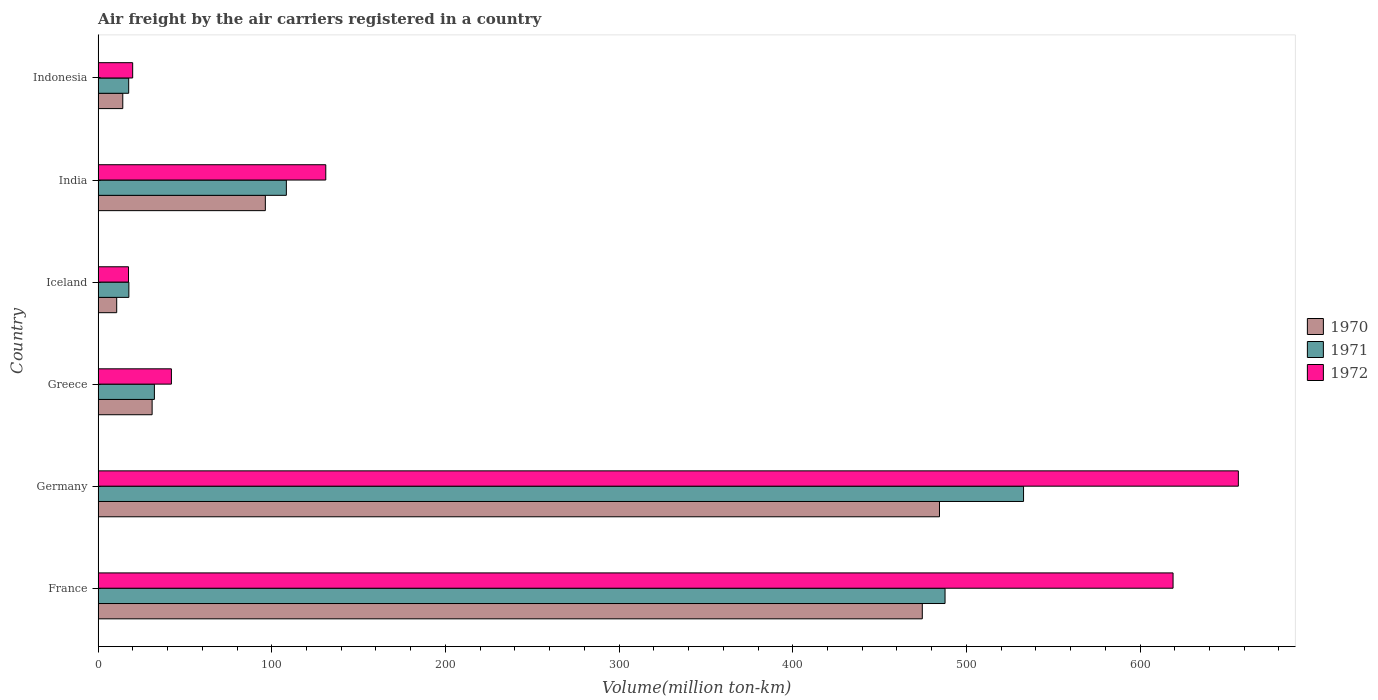How many groups of bars are there?
Ensure brevity in your answer.  6. Are the number of bars on each tick of the Y-axis equal?
Offer a very short reply. Yes. How many bars are there on the 6th tick from the top?
Offer a very short reply. 3. How many bars are there on the 3rd tick from the bottom?
Provide a short and direct response. 3. What is the label of the 6th group of bars from the top?
Ensure brevity in your answer.  France. What is the volume of the air carriers in 1972 in Iceland?
Provide a short and direct response. 17.5. Across all countries, what is the maximum volume of the air carriers in 1971?
Your answer should be compact. 532.9. Across all countries, what is the minimum volume of the air carriers in 1971?
Keep it short and to the point. 17.6. In which country was the volume of the air carriers in 1972 minimum?
Ensure brevity in your answer.  Iceland. What is the total volume of the air carriers in 1972 in the graph?
Offer a very short reply. 1486.3. What is the difference between the volume of the air carriers in 1970 in Germany and that in Iceland?
Your answer should be very brief. 473.8. What is the difference between the volume of the air carriers in 1971 in Greece and the volume of the air carriers in 1972 in Indonesia?
Your response must be concise. 12.5. What is the average volume of the air carriers in 1972 per country?
Your response must be concise. 247.72. What is the difference between the volume of the air carriers in 1970 and volume of the air carriers in 1972 in Germany?
Offer a very short reply. -172.1. What is the ratio of the volume of the air carriers in 1970 in France to that in Indonesia?
Ensure brevity in your answer.  33.42. What is the difference between the highest and the second highest volume of the air carriers in 1972?
Make the answer very short. 37.6. What is the difference between the highest and the lowest volume of the air carriers in 1972?
Make the answer very short. 639.1. What does the 2nd bar from the bottom in Germany represents?
Your answer should be very brief. 1971. How many bars are there?
Give a very brief answer. 18. How many countries are there in the graph?
Offer a very short reply. 6. Are the values on the major ticks of X-axis written in scientific E-notation?
Give a very brief answer. No. Does the graph contain any zero values?
Offer a terse response. No. Does the graph contain grids?
Offer a very short reply. No. How many legend labels are there?
Offer a terse response. 3. What is the title of the graph?
Offer a very short reply. Air freight by the air carriers registered in a country. What is the label or title of the X-axis?
Your answer should be very brief. Volume(million ton-km). What is the Volume(million ton-km) of 1970 in France?
Keep it short and to the point. 474.6. What is the Volume(million ton-km) in 1971 in France?
Keep it short and to the point. 487.7. What is the Volume(million ton-km) of 1972 in France?
Offer a terse response. 619. What is the Volume(million ton-km) of 1970 in Germany?
Offer a very short reply. 484.5. What is the Volume(million ton-km) of 1971 in Germany?
Your answer should be very brief. 532.9. What is the Volume(million ton-km) in 1972 in Germany?
Keep it short and to the point. 656.6. What is the Volume(million ton-km) of 1970 in Greece?
Provide a succinct answer. 31.1. What is the Volume(million ton-km) in 1971 in Greece?
Make the answer very short. 32.4. What is the Volume(million ton-km) of 1972 in Greece?
Keep it short and to the point. 42.2. What is the Volume(million ton-km) of 1970 in Iceland?
Offer a terse response. 10.7. What is the Volume(million ton-km) of 1971 in Iceland?
Your answer should be very brief. 17.7. What is the Volume(million ton-km) of 1970 in India?
Ensure brevity in your answer.  96.3. What is the Volume(million ton-km) in 1971 in India?
Offer a very short reply. 108.4. What is the Volume(million ton-km) of 1972 in India?
Provide a succinct answer. 131.1. What is the Volume(million ton-km) in 1970 in Indonesia?
Give a very brief answer. 14.2. What is the Volume(million ton-km) in 1971 in Indonesia?
Give a very brief answer. 17.6. What is the Volume(million ton-km) of 1972 in Indonesia?
Offer a very short reply. 19.9. Across all countries, what is the maximum Volume(million ton-km) of 1970?
Your answer should be very brief. 484.5. Across all countries, what is the maximum Volume(million ton-km) of 1971?
Provide a succinct answer. 532.9. Across all countries, what is the maximum Volume(million ton-km) in 1972?
Keep it short and to the point. 656.6. Across all countries, what is the minimum Volume(million ton-km) in 1970?
Keep it short and to the point. 10.7. Across all countries, what is the minimum Volume(million ton-km) of 1971?
Provide a short and direct response. 17.6. Across all countries, what is the minimum Volume(million ton-km) in 1972?
Make the answer very short. 17.5. What is the total Volume(million ton-km) in 1970 in the graph?
Your answer should be compact. 1111.4. What is the total Volume(million ton-km) of 1971 in the graph?
Offer a terse response. 1196.7. What is the total Volume(million ton-km) in 1972 in the graph?
Keep it short and to the point. 1486.3. What is the difference between the Volume(million ton-km) in 1970 in France and that in Germany?
Ensure brevity in your answer.  -9.9. What is the difference between the Volume(million ton-km) in 1971 in France and that in Germany?
Your response must be concise. -45.2. What is the difference between the Volume(million ton-km) in 1972 in France and that in Germany?
Offer a terse response. -37.6. What is the difference between the Volume(million ton-km) in 1970 in France and that in Greece?
Offer a terse response. 443.5. What is the difference between the Volume(million ton-km) of 1971 in France and that in Greece?
Offer a terse response. 455.3. What is the difference between the Volume(million ton-km) of 1972 in France and that in Greece?
Offer a terse response. 576.8. What is the difference between the Volume(million ton-km) in 1970 in France and that in Iceland?
Provide a short and direct response. 463.9. What is the difference between the Volume(million ton-km) of 1971 in France and that in Iceland?
Give a very brief answer. 470. What is the difference between the Volume(million ton-km) of 1972 in France and that in Iceland?
Give a very brief answer. 601.5. What is the difference between the Volume(million ton-km) of 1970 in France and that in India?
Ensure brevity in your answer.  378.3. What is the difference between the Volume(million ton-km) in 1971 in France and that in India?
Give a very brief answer. 379.3. What is the difference between the Volume(million ton-km) in 1972 in France and that in India?
Ensure brevity in your answer.  487.9. What is the difference between the Volume(million ton-km) in 1970 in France and that in Indonesia?
Give a very brief answer. 460.4. What is the difference between the Volume(million ton-km) of 1971 in France and that in Indonesia?
Make the answer very short. 470.1. What is the difference between the Volume(million ton-km) in 1972 in France and that in Indonesia?
Make the answer very short. 599.1. What is the difference between the Volume(million ton-km) in 1970 in Germany and that in Greece?
Keep it short and to the point. 453.4. What is the difference between the Volume(million ton-km) of 1971 in Germany and that in Greece?
Provide a short and direct response. 500.5. What is the difference between the Volume(million ton-km) in 1972 in Germany and that in Greece?
Your answer should be compact. 614.4. What is the difference between the Volume(million ton-km) of 1970 in Germany and that in Iceland?
Give a very brief answer. 473.8. What is the difference between the Volume(million ton-km) of 1971 in Germany and that in Iceland?
Provide a short and direct response. 515.2. What is the difference between the Volume(million ton-km) of 1972 in Germany and that in Iceland?
Your answer should be compact. 639.1. What is the difference between the Volume(million ton-km) in 1970 in Germany and that in India?
Provide a short and direct response. 388.2. What is the difference between the Volume(million ton-km) of 1971 in Germany and that in India?
Offer a very short reply. 424.5. What is the difference between the Volume(million ton-km) in 1972 in Germany and that in India?
Keep it short and to the point. 525.5. What is the difference between the Volume(million ton-km) of 1970 in Germany and that in Indonesia?
Provide a short and direct response. 470.3. What is the difference between the Volume(million ton-km) of 1971 in Germany and that in Indonesia?
Provide a short and direct response. 515.3. What is the difference between the Volume(million ton-km) of 1972 in Germany and that in Indonesia?
Ensure brevity in your answer.  636.7. What is the difference between the Volume(million ton-km) in 1970 in Greece and that in Iceland?
Your response must be concise. 20.4. What is the difference between the Volume(million ton-km) in 1972 in Greece and that in Iceland?
Make the answer very short. 24.7. What is the difference between the Volume(million ton-km) in 1970 in Greece and that in India?
Offer a very short reply. -65.2. What is the difference between the Volume(million ton-km) in 1971 in Greece and that in India?
Provide a short and direct response. -76. What is the difference between the Volume(million ton-km) in 1972 in Greece and that in India?
Provide a succinct answer. -88.9. What is the difference between the Volume(million ton-km) in 1970 in Greece and that in Indonesia?
Offer a very short reply. 16.9. What is the difference between the Volume(million ton-km) in 1972 in Greece and that in Indonesia?
Provide a succinct answer. 22.3. What is the difference between the Volume(million ton-km) of 1970 in Iceland and that in India?
Provide a succinct answer. -85.6. What is the difference between the Volume(million ton-km) of 1971 in Iceland and that in India?
Your answer should be very brief. -90.7. What is the difference between the Volume(million ton-km) in 1972 in Iceland and that in India?
Offer a very short reply. -113.6. What is the difference between the Volume(million ton-km) of 1972 in Iceland and that in Indonesia?
Ensure brevity in your answer.  -2.4. What is the difference between the Volume(million ton-km) of 1970 in India and that in Indonesia?
Provide a succinct answer. 82.1. What is the difference between the Volume(million ton-km) of 1971 in India and that in Indonesia?
Make the answer very short. 90.8. What is the difference between the Volume(million ton-km) in 1972 in India and that in Indonesia?
Give a very brief answer. 111.2. What is the difference between the Volume(million ton-km) in 1970 in France and the Volume(million ton-km) in 1971 in Germany?
Your answer should be compact. -58.3. What is the difference between the Volume(million ton-km) of 1970 in France and the Volume(million ton-km) of 1972 in Germany?
Your answer should be very brief. -182. What is the difference between the Volume(million ton-km) of 1971 in France and the Volume(million ton-km) of 1972 in Germany?
Your answer should be compact. -168.9. What is the difference between the Volume(million ton-km) of 1970 in France and the Volume(million ton-km) of 1971 in Greece?
Keep it short and to the point. 442.2. What is the difference between the Volume(million ton-km) in 1970 in France and the Volume(million ton-km) in 1972 in Greece?
Provide a succinct answer. 432.4. What is the difference between the Volume(million ton-km) of 1971 in France and the Volume(million ton-km) of 1972 in Greece?
Ensure brevity in your answer.  445.5. What is the difference between the Volume(million ton-km) of 1970 in France and the Volume(million ton-km) of 1971 in Iceland?
Make the answer very short. 456.9. What is the difference between the Volume(million ton-km) of 1970 in France and the Volume(million ton-km) of 1972 in Iceland?
Provide a succinct answer. 457.1. What is the difference between the Volume(million ton-km) of 1971 in France and the Volume(million ton-km) of 1972 in Iceland?
Your response must be concise. 470.2. What is the difference between the Volume(million ton-km) in 1970 in France and the Volume(million ton-km) in 1971 in India?
Keep it short and to the point. 366.2. What is the difference between the Volume(million ton-km) of 1970 in France and the Volume(million ton-km) of 1972 in India?
Your answer should be compact. 343.5. What is the difference between the Volume(million ton-km) of 1971 in France and the Volume(million ton-km) of 1972 in India?
Make the answer very short. 356.6. What is the difference between the Volume(million ton-km) in 1970 in France and the Volume(million ton-km) in 1971 in Indonesia?
Provide a succinct answer. 457. What is the difference between the Volume(million ton-km) in 1970 in France and the Volume(million ton-km) in 1972 in Indonesia?
Provide a short and direct response. 454.7. What is the difference between the Volume(million ton-km) in 1971 in France and the Volume(million ton-km) in 1972 in Indonesia?
Offer a very short reply. 467.8. What is the difference between the Volume(million ton-km) of 1970 in Germany and the Volume(million ton-km) of 1971 in Greece?
Offer a terse response. 452.1. What is the difference between the Volume(million ton-km) of 1970 in Germany and the Volume(million ton-km) of 1972 in Greece?
Provide a short and direct response. 442.3. What is the difference between the Volume(million ton-km) of 1971 in Germany and the Volume(million ton-km) of 1972 in Greece?
Your answer should be compact. 490.7. What is the difference between the Volume(million ton-km) of 1970 in Germany and the Volume(million ton-km) of 1971 in Iceland?
Give a very brief answer. 466.8. What is the difference between the Volume(million ton-km) of 1970 in Germany and the Volume(million ton-km) of 1972 in Iceland?
Provide a short and direct response. 467. What is the difference between the Volume(million ton-km) in 1971 in Germany and the Volume(million ton-km) in 1972 in Iceland?
Keep it short and to the point. 515.4. What is the difference between the Volume(million ton-km) of 1970 in Germany and the Volume(million ton-km) of 1971 in India?
Provide a short and direct response. 376.1. What is the difference between the Volume(million ton-km) of 1970 in Germany and the Volume(million ton-km) of 1972 in India?
Your answer should be compact. 353.4. What is the difference between the Volume(million ton-km) in 1971 in Germany and the Volume(million ton-km) in 1972 in India?
Offer a very short reply. 401.8. What is the difference between the Volume(million ton-km) in 1970 in Germany and the Volume(million ton-km) in 1971 in Indonesia?
Provide a short and direct response. 466.9. What is the difference between the Volume(million ton-km) in 1970 in Germany and the Volume(million ton-km) in 1972 in Indonesia?
Your answer should be very brief. 464.6. What is the difference between the Volume(million ton-km) in 1971 in Germany and the Volume(million ton-km) in 1972 in Indonesia?
Keep it short and to the point. 513. What is the difference between the Volume(million ton-km) in 1970 in Greece and the Volume(million ton-km) in 1971 in Iceland?
Your response must be concise. 13.4. What is the difference between the Volume(million ton-km) of 1970 in Greece and the Volume(million ton-km) of 1972 in Iceland?
Provide a short and direct response. 13.6. What is the difference between the Volume(million ton-km) of 1970 in Greece and the Volume(million ton-km) of 1971 in India?
Your answer should be compact. -77.3. What is the difference between the Volume(million ton-km) in 1970 in Greece and the Volume(million ton-km) in 1972 in India?
Your response must be concise. -100. What is the difference between the Volume(million ton-km) of 1971 in Greece and the Volume(million ton-km) of 1972 in India?
Your answer should be very brief. -98.7. What is the difference between the Volume(million ton-km) in 1970 in Greece and the Volume(million ton-km) in 1971 in Indonesia?
Provide a succinct answer. 13.5. What is the difference between the Volume(million ton-km) in 1970 in Iceland and the Volume(million ton-km) in 1971 in India?
Provide a short and direct response. -97.7. What is the difference between the Volume(million ton-km) in 1970 in Iceland and the Volume(million ton-km) in 1972 in India?
Provide a short and direct response. -120.4. What is the difference between the Volume(million ton-km) in 1971 in Iceland and the Volume(million ton-km) in 1972 in India?
Offer a terse response. -113.4. What is the difference between the Volume(million ton-km) of 1970 in India and the Volume(million ton-km) of 1971 in Indonesia?
Your answer should be compact. 78.7. What is the difference between the Volume(million ton-km) in 1970 in India and the Volume(million ton-km) in 1972 in Indonesia?
Offer a terse response. 76.4. What is the difference between the Volume(million ton-km) in 1971 in India and the Volume(million ton-km) in 1972 in Indonesia?
Keep it short and to the point. 88.5. What is the average Volume(million ton-km) of 1970 per country?
Keep it short and to the point. 185.23. What is the average Volume(million ton-km) in 1971 per country?
Ensure brevity in your answer.  199.45. What is the average Volume(million ton-km) of 1972 per country?
Your response must be concise. 247.72. What is the difference between the Volume(million ton-km) in 1970 and Volume(million ton-km) in 1972 in France?
Provide a succinct answer. -144.4. What is the difference between the Volume(million ton-km) of 1971 and Volume(million ton-km) of 1972 in France?
Keep it short and to the point. -131.3. What is the difference between the Volume(million ton-km) of 1970 and Volume(million ton-km) of 1971 in Germany?
Your response must be concise. -48.4. What is the difference between the Volume(million ton-km) of 1970 and Volume(million ton-km) of 1972 in Germany?
Give a very brief answer. -172.1. What is the difference between the Volume(million ton-km) of 1971 and Volume(million ton-km) of 1972 in Germany?
Make the answer very short. -123.7. What is the difference between the Volume(million ton-km) in 1970 and Volume(million ton-km) in 1971 in Greece?
Make the answer very short. -1.3. What is the difference between the Volume(million ton-km) in 1970 and Volume(million ton-km) in 1972 in Greece?
Your answer should be very brief. -11.1. What is the difference between the Volume(million ton-km) of 1970 and Volume(million ton-km) of 1971 in Iceland?
Your response must be concise. -7. What is the difference between the Volume(million ton-km) in 1970 and Volume(million ton-km) in 1972 in Iceland?
Offer a terse response. -6.8. What is the difference between the Volume(million ton-km) of 1970 and Volume(million ton-km) of 1971 in India?
Your response must be concise. -12.1. What is the difference between the Volume(million ton-km) in 1970 and Volume(million ton-km) in 1972 in India?
Provide a short and direct response. -34.8. What is the difference between the Volume(million ton-km) in 1971 and Volume(million ton-km) in 1972 in India?
Ensure brevity in your answer.  -22.7. What is the ratio of the Volume(million ton-km) in 1970 in France to that in Germany?
Give a very brief answer. 0.98. What is the ratio of the Volume(million ton-km) of 1971 in France to that in Germany?
Ensure brevity in your answer.  0.92. What is the ratio of the Volume(million ton-km) in 1972 in France to that in Germany?
Provide a succinct answer. 0.94. What is the ratio of the Volume(million ton-km) of 1970 in France to that in Greece?
Offer a very short reply. 15.26. What is the ratio of the Volume(million ton-km) in 1971 in France to that in Greece?
Make the answer very short. 15.05. What is the ratio of the Volume(million ton-km) in 1972 in France to that in Greece?
Your response must be concise. 14.67. What is the ratio of the Volume(million ton-km) in 1970 in France to that in Iceland?
Provide a succinct answer. 44.36. What is the ratio of the Volume(million ton-km) in 1971 in France to that in Iceland?
Your answer should be very brief. 27.55. What is the ratio of the Volume(million ton-km) of 1972 in France to that in Iceland?
Offer a terse response. 35.37. What is the ratio of the Volume(million ton-km) in 1970 in France to that in India?
Provide a short and direct response. 4.93. What is the ratio of the Volume(million ton-km) in 1971 in France to that in India?
Your response must be concise. 4.5. What is the ratio of the Volume(million ton-km) in 1972 in France to that in India?
Make the answer very short. 4.72. What is the ratio of the Volume(million ton-km) of 1970 in France to that in Indonesia?
Your response must be concise. 33.42. What is the ratio of the Volume(million ton-km) in 1971 in France to that in Indonesia?
Provide a short and direct response. 27.71. What is the ratio of the Volume(million ton-km) of 1972 in France to that in Indonesia?
Offer a very short reply. 31.11. What is the ratio of the Volume(million ton-km) of 1970 in Germany to that in Greece?
Offer a very short reply. 15.58. What is the ratio of the Volume(million ton-km) in 1971 in Germany to that in Greece?
Your answer should be compact. 16.45. What is the ratio of the Volume(million ton-km) in 1972 in Germany to that in Greece?
Your answer should be compact. 15.56. What is the ratio of the Volume(million ton-km) in 1970 in Germany to that in Iceland?
Your response must be concise. 45.28. What is the ratio of the Volume(million ton-km) of 1971 in Germany to that in Iceland?
Ensure brevity in your answer.  30.11. What is the ratio of the Volume(million ton-km) in 1972 in Germany to that in Iceland?
Offer a terse response. 37.52. What is the ratio of the Volume(million ton-km) in 1970 in Germany to that in India?
Your answer should be compact. 5.03. What is the ratio of the Volume(million ton-km) of 1971 in Germany to that in India?
Ensure brevity in your answer.  4.92. What is the ratio of the Volume(million ton-km) in 1972 in Germany to that in India?
Make the answer very short. 5.01. What is the ratio of the Volume(million ton-km) in 1970 in Germany to that in Indonesia?
Ensure brevity in your answer.  34.12. What is the ratio of the Volume(million ton-km) of 1971 in Germany to that in Indonesia?
Keep it short and to the point. 30.28. What is the ratio of the Volume(million ton-km) of 1972 in Germany to that in Indonesia?
Your response must be concise. 32.99. What is the ratio of the Volume(million ton-km) of 1970 in Greece to that in Iceland?
Offer a very short reply. 2.91. What is the ratio of the Volume(million ton-km) of 1971 in Greece to that in Iceland?
Ensure brevity in your answer.  1.83. What is the ratio of the Volume(million ton-km) of 1972 in Greece to that in Iceland?
Offer a terse response. 2.41. What is the ratio of the Volume(million ton-km) of 1970 in Greece to that in India?
Ensure brevity in your answer.  0.32. What is the ratio of the Volume(million ton-km) in 1971 in Greece to that in India?
Your response must be concise. 0.3. What is the ratio of the Volume(million ton-km) in 1972 in Greece to that in India?
Your answer should be compact. 0.32. What is the ratio of the Volume(million ton-km) in 1970 in Greece to that in Indonesia?
Your response must be concise. 2.19. What is the ratio of the Volume(million ton-km) of 1971 in Greece to that in Indonesia?
Your answer should be very brief. 1.84. What is the ratio of the Volume(million ton-km) in 1972 in Greece to that in Indonesia?
Keep it short and to the point. 2.12. What is the ratio of the Volume(million ton-km) in 1971 in Iceland to that in India?
Offer a terse response. 0.16. What is the ratio of the Volume(million ton-km) of 1972 in Iceland to that in India?
Offer a very short reply. 0.13. What is the ratio of the Volume(million ton-km) in 1970 in Iceland to that in Indonesia?
Keep it short and to the point. 0.75. What is the ratio of the Volume(million ton-km) in 1972 in Iceland to that in Indonesia?
Provide a short and direct response. 0.88. What is the ratio of the Volume(million ton-km) of 1970 in India to that in Indonesia?
Offer a terse response. 6.78. What is the ratio of the Volume(million ton-km) in 1971 in India to that in Indonesia?
Your answer should be compact. 6.16. What is the ratio of the Volume(million ton-km) of 1972 in India to that in Indonesia?
Give a very brief answer. 6.59. What is the difference between the highest and the second highest Volume(million ton-km) of 1971?
Provide a succinct answer. 45.2. What is the difference between the highest and the second highest Volume(million ton-km) in 1972?
Offer a very short reply. 37.6. What is the difference between the highest and the lowest Volume(million ton-km) of 1970?
Give a very brief answer. 473.8. What is the difference between the highest and the lowest Volume(million ton-km) in 1971?
Give a very brief answer. 515.3. What is the difference between the highest and the lowest Volume(million ton-km) of 1972?
Offer a terse response. 639.1. 